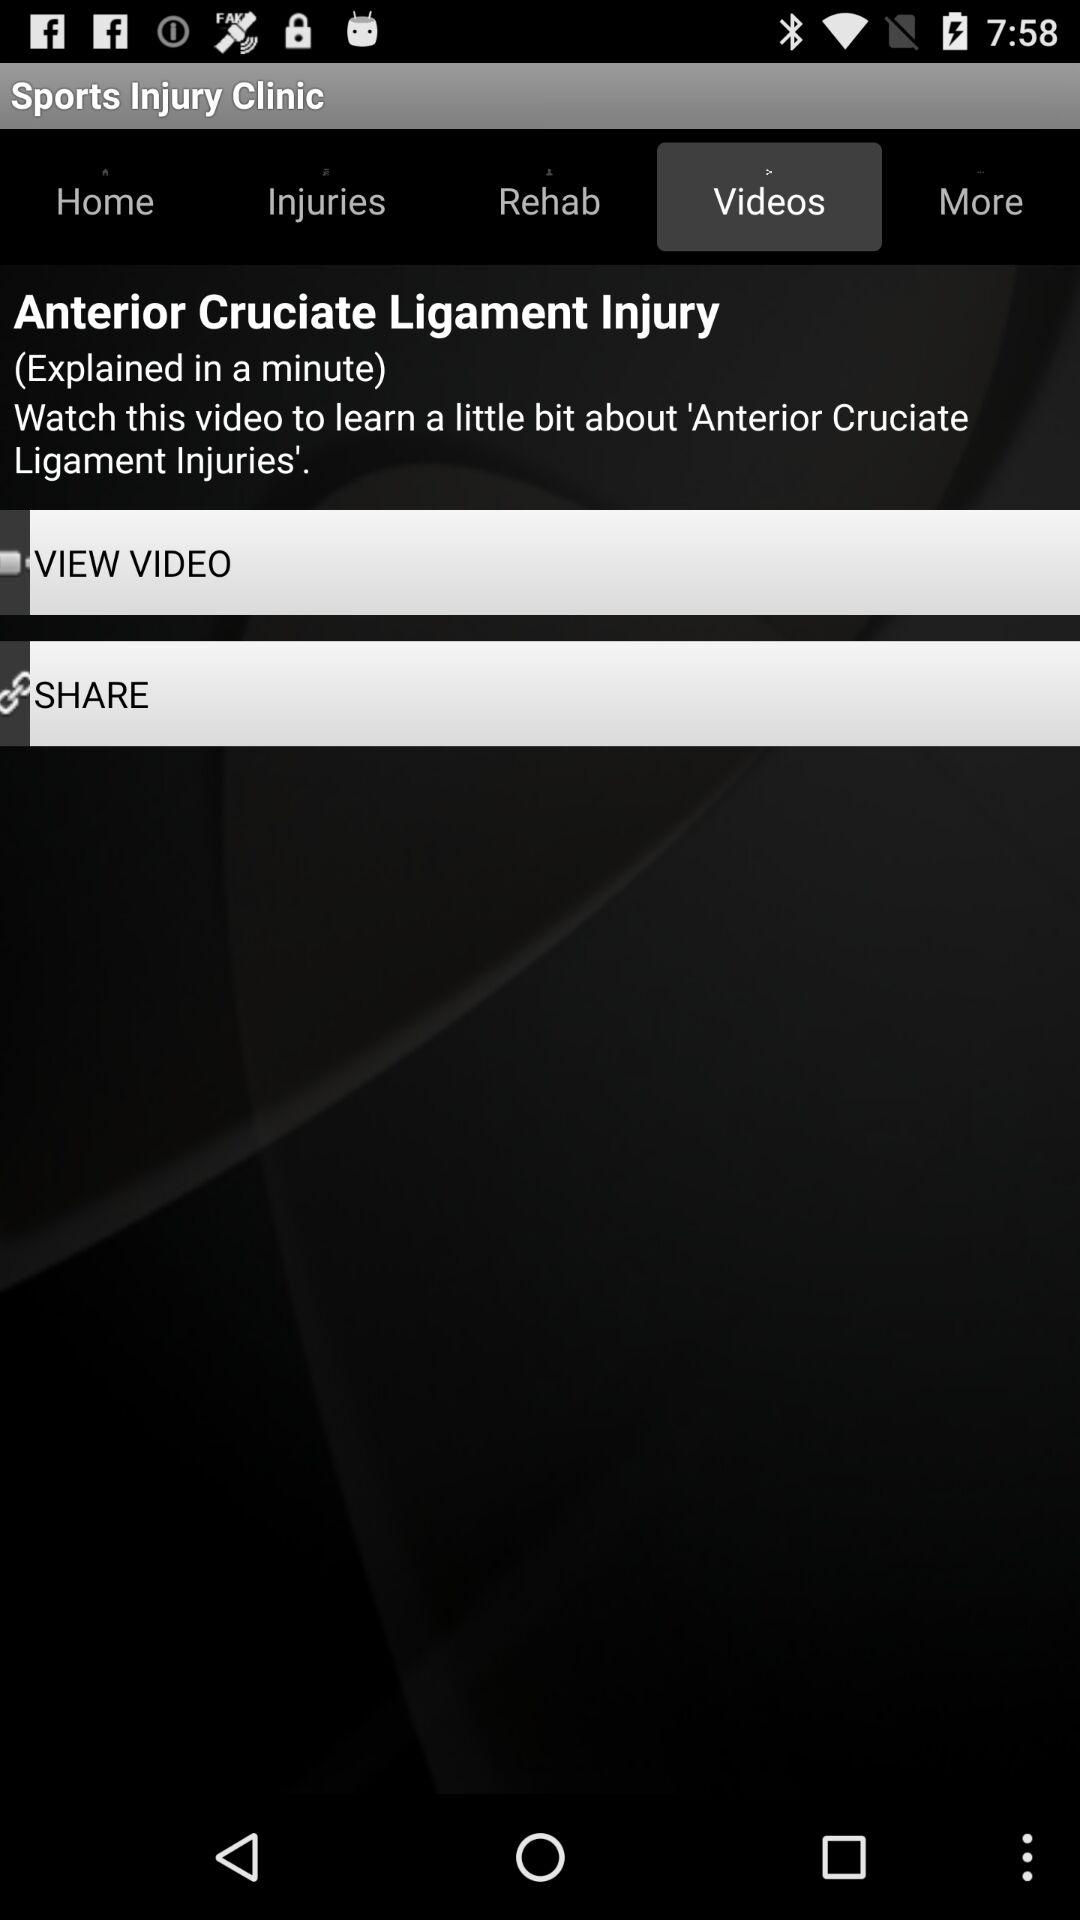Which tab is selected? The selected tab is "Videos". 